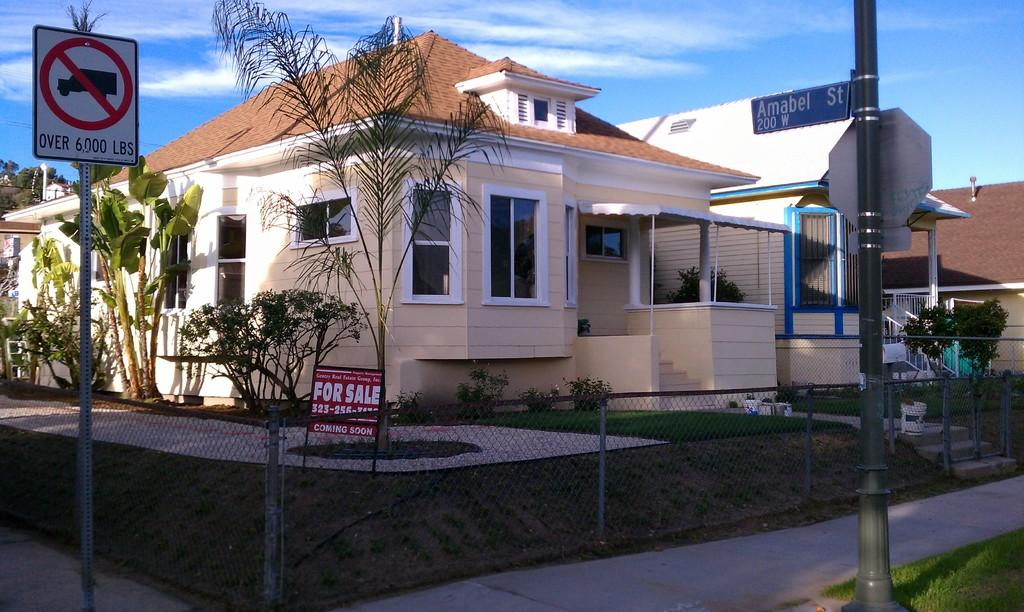<image>
Share a concise interpretation of the image provided. A yellow house has a for sale sign in the front yard. 